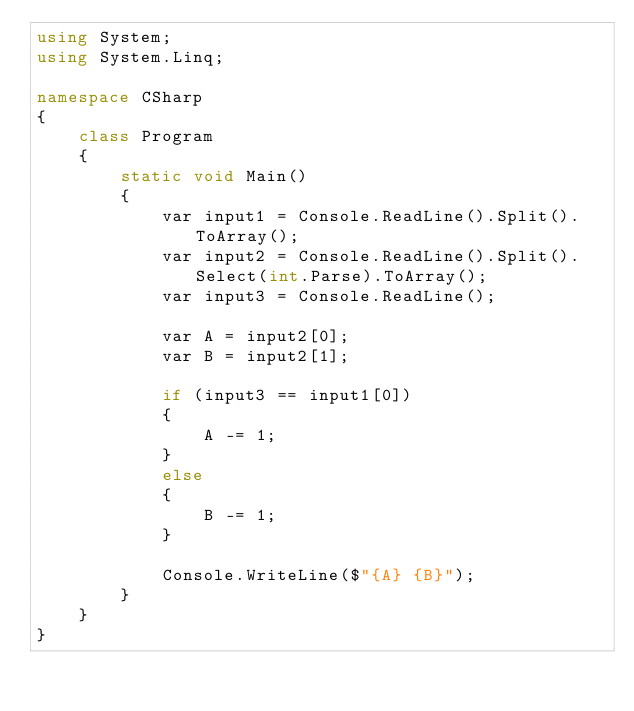Convert code to text. <code><loc_0><loc_0><loc_500><loc_500><_C#_>using System;
using System.Linq;

namespace CSharp
{
    class Program
    {
        static void Main()
        {
            var input1 = Console.ReadLine().Split().ToArray();
            var input2 = Console.ReadLine().Split().Select(int.Parse).ToArray();
            var input3 = Console.ReadLine();

            var A = input2[0];
            var B = input2[1];

            if (input3 == input1[0])
            {
                A -= 1;
            }
            else
            {
                B -= 1;
            }

            Console.WriteLine($"{A} {B}");
        }
    }
}</code> 